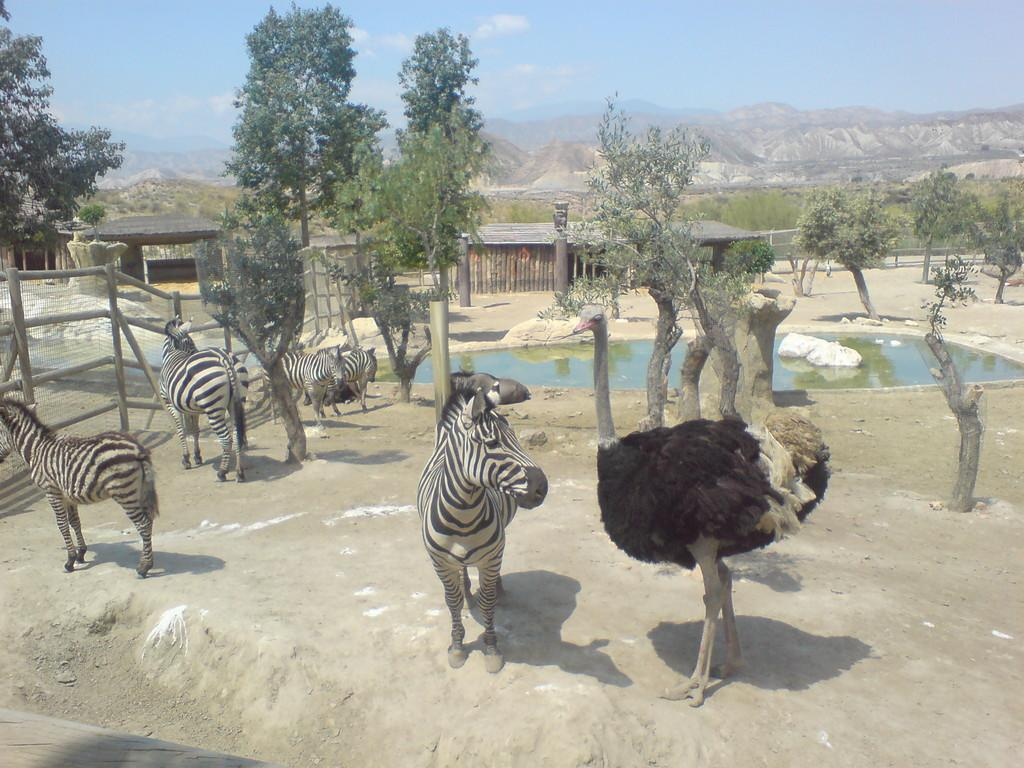What type of animals can be seen in the image? There are zebras and an ostrich in the image. What can be seen in the background of the image? There are trees, sheds, and poles in the background of the image. What is located at the bottom of the image? There is a pond at the bottom of the image. What type of secretary can be seen working in the image? There is no secretary present in the image; it features zebras, an ostrich, trees, sheds, poles, and a pond. Can you tell me how many times the zebras bite each other in the image? There is no indication of any biting behavior among the zebras in the image. 